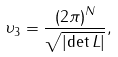<formula> <loc_0><loc_0><loc_500><loc_500>\upsilon _ { 3 } = \frac { \left ( 2 \pi \right ) ^ { N } } { \sqrt { \left | \det L \right | } } ,</formula> 